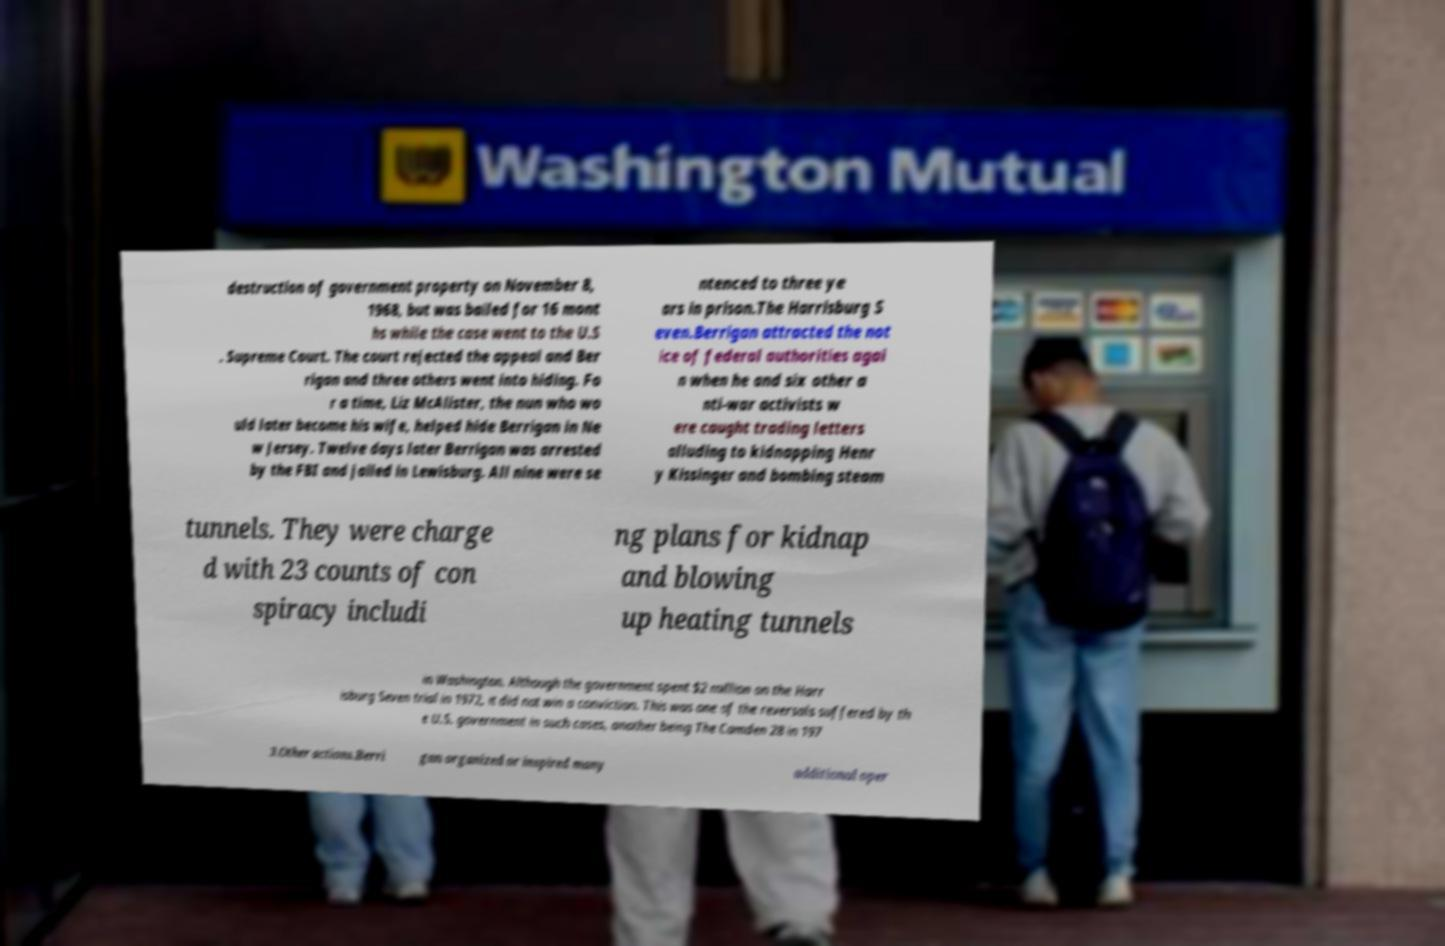Can you read and provide the text displayed in the image?This photo seems to have some interesting text. Can you extract and type it out for me? destruction of government property on November 8, 1968, but was bailed for 16 mont hs while the case went to the U.S . Supreme Court. The court rejected the appeal and Ber rigan and three others went into hiding. Fo r a time, Liz McAlister, the nun who wo uld later become his wife, helped hide Berrigan in Ne w Jersey. Twelve days later Berrigan was arrested by the FBI and jailed in Lewisburg. All nine were se ntenced to three ye ars in prison.The Harrisburg S even.Berrigan attracted the not ice of federal authorities agai n when he and six other a nti-war activists w ere caught trading letters alluding to kidnapping Henr y Kissinger and bombing steam tunnels. They were charge d with 23 counts of con spiracy includi ng plans for kidnap and blowing up heating tunnels in Washington. Although the government spent $2 million on the Harr isburg Seven trial in 1972, it did not win a conviction. This was one of the reversals suffered by th e U.S. government in such cases, another being The Camden 28 in 197 3.Other actions.Berri gan organized or inspired many additional oper 